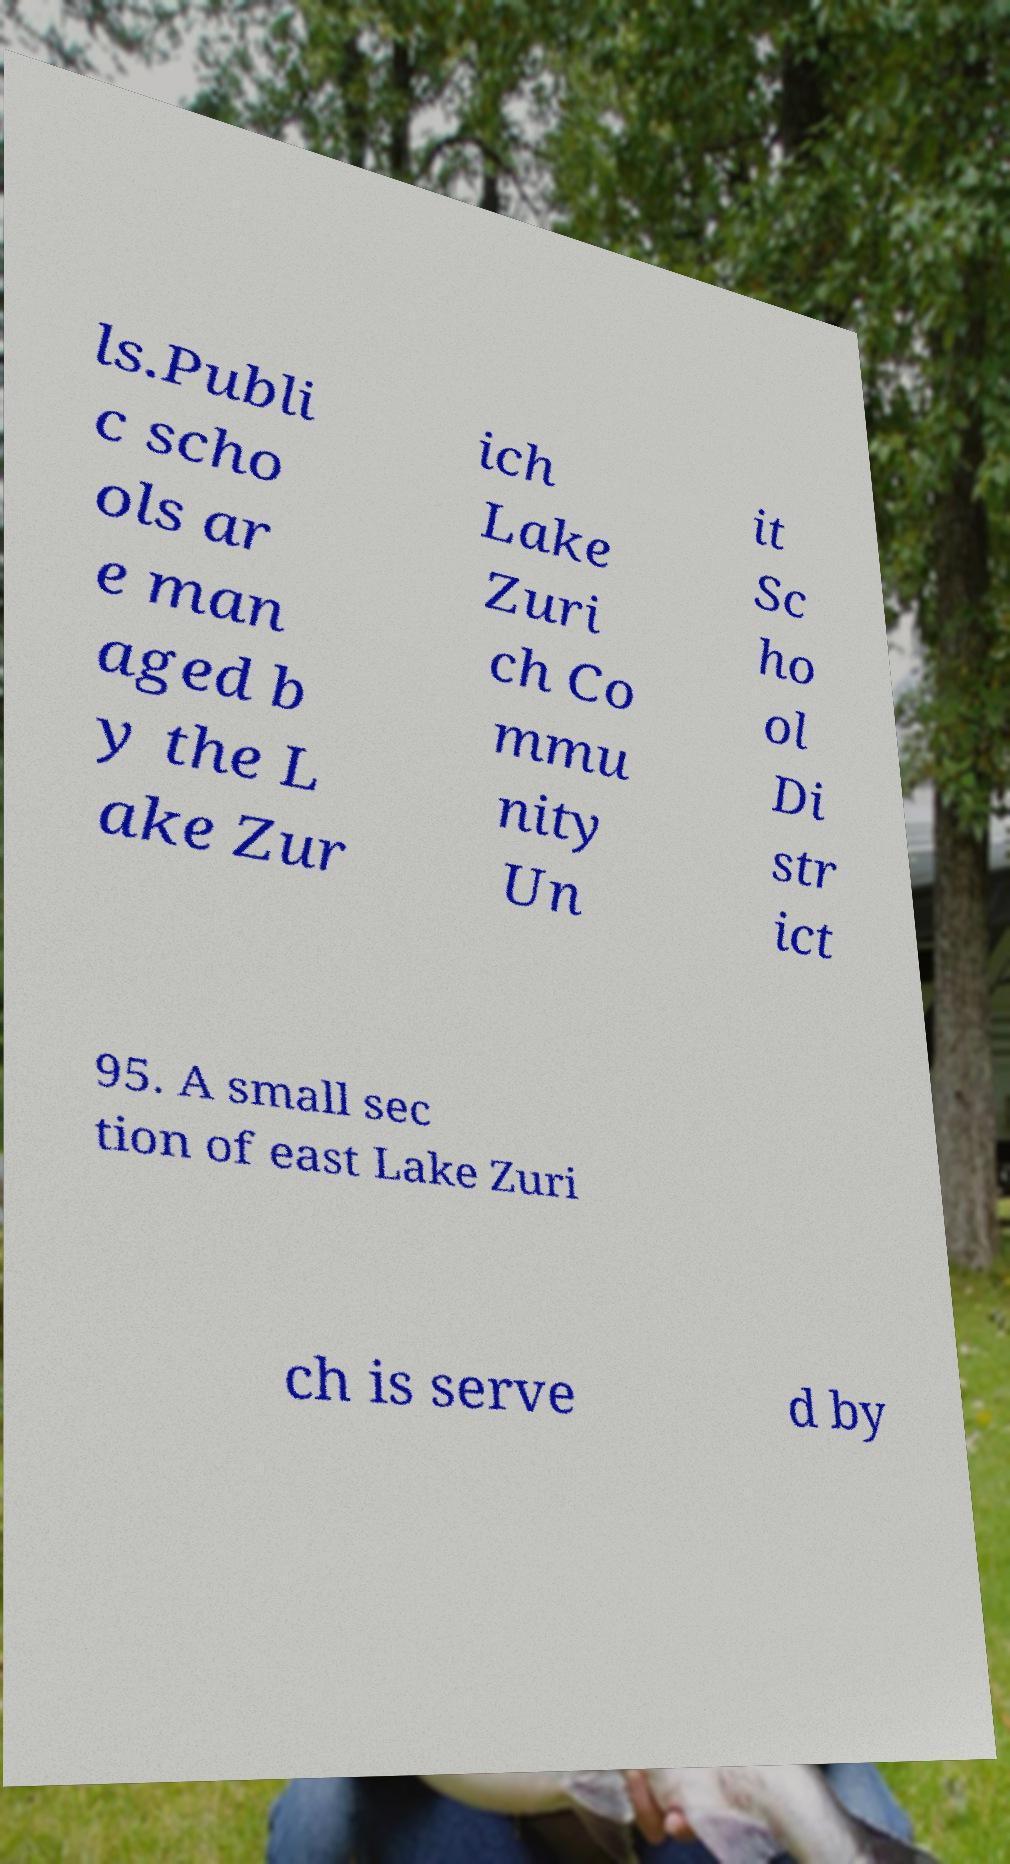Please identify and transcribe the text found in this image. ls.Publi c scho ols ar e man aged b y the L ake Zur ich Lake Zuri ch Co mmu nity Un it Sc ho ol Di str ict 95. A small sec tion of east Lake Zuri ch is serve d by 